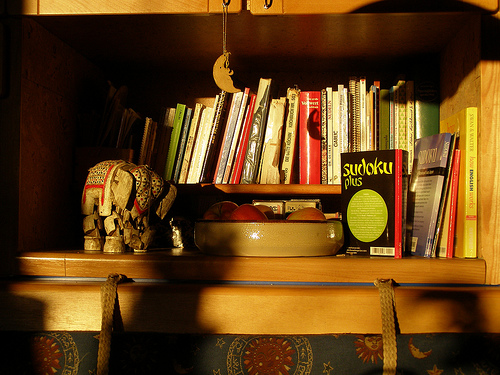<image>
Is there a bowl behind the book? No. The bowl is not behind the book. From this viewpoint, the bowl appears to be positioned elsewhere in the scene. Is the title on the book? No. The title is not positioned on the book. They may be near each other, but the title is not supported by or resting on top of the book. 